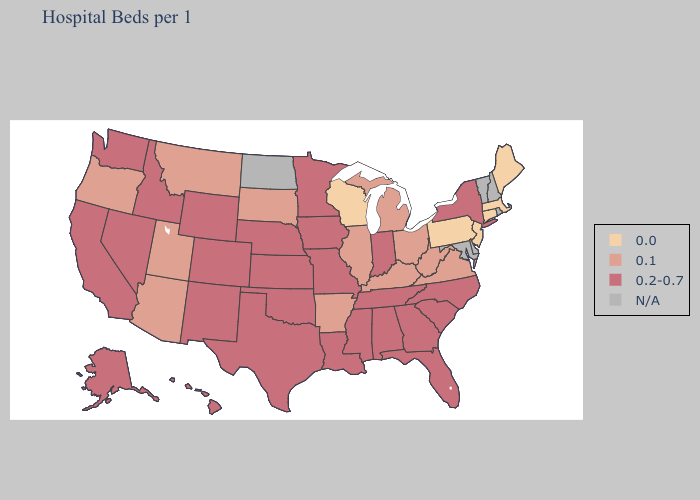How many symbols are there in the legend?
Be succinct. 4. Does Illinois have the highest value in the MidWest?
Keep it brief. No. Name the states that have a value in the range N/A?
Short answer required. Delaware, Maryland, New Hampshire, North Dakota, Rhode Island, Vermont. Name the states that have a value in the range 0.2-0.7?
Keep it brief. Alabama, Alaska, California, Colorado, Florida, Georgia, Hawaii, Idaho, Indiana, Iowa, Kansas, Louisiana, Minnesota, Mississippi, Missouri, Nebraska, Nevada, New Mexico, New York, North Carolina, Oklahoma, South Carolina, Tennessee, Texas, Washington, Wyoming. Name the states that have a value in the range N/A?
Write a very short answer. Delaware, Maryland, New Hampshire, North Dakota, Rhode Island, Vermont. Name the states that have a value in the range 0.1?
Keep it brief. Arizona, Arkansas, Illinois, Kentucky, Michigan, Montana, Ohio, Oregon, South Dakota, Utah, Virginia, West Virginia. What is the value of Mississippi?
Be succinct. 0.2-0.7. Which states have the highest value in the USA?
Answer briefly. Alabama, Alaska, California, Colorado, Florida, Georgia, Hawaii, Idaho, Indiana, Iowa, Kansas, Louisiana, Minnesota, Mississippi, Missouri, Nebraska, Nevada, New Mexico, New York, North Carolina, Oklahoma, South Carolina, Tennessee, Texas, Washington, Wyoming. Does the first symbol in the legend represent the smallest category?
Keep it brief. Yes. What is the lowest value in the USA?
Keep it brief. 0.0. Name the states that have a value in the range 0.2-0.7?
Give a very brief answer. Alabama, Alaska, California, Colorado, Florida, Georgia, Hawaii, Idaho, Indiana, Iowa, Kansas, Louisiana, Minnesota, Mississippi, Missouri, Nebraska, Nevada, New Mexico, New York, North Carolina, Oklahoma, South Carolina, Tennessee, Texas, Washington, Wyoming. Name the states that have a value in the range 0.2-0.7?
Keep it brief. Alabama, Alaska, California, Colorado, Florida, Georgia, Hawaii, Idaho, Indiana, Iowa, Kansas, Louisiana, Minnesota, Mississippi, Missouri, Nebraska, Nevada, New Mexico, New York, North Carolina, Oklahoma, South Carolina, Tennessee, Texas, Washington, Wyoming. Name the states that have a value in the range N/A?
Be succinct. Delaware, Maryland, New Hampshire, North Dakota, Rhode Island, Vermont. What is the value of Utah?
Keep it brief. 0.1. Does Connecticut have the highest value in the USA?
Give a very brief answer. No. 